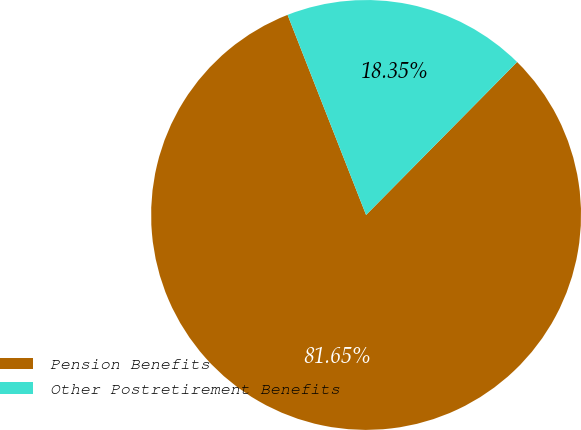Convert chart to OTSL. <chart><loc_0><loc_0><loc_500><loc_500><pie_chart><fcel>Pension Benefits<fcel>Other Postretirement Benefits<nl><fcel>81.65%<fcel>18.35%<nl></chart> 